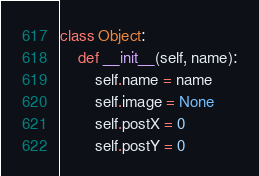Convert code to text. <code><loc_0><loc_0><loc_500><loc_500><_Python_>class Object:
    def __init__(self, name):
        self.name = name
        self.image = None
        self.postX = 0
        self.postY = 0</code> 